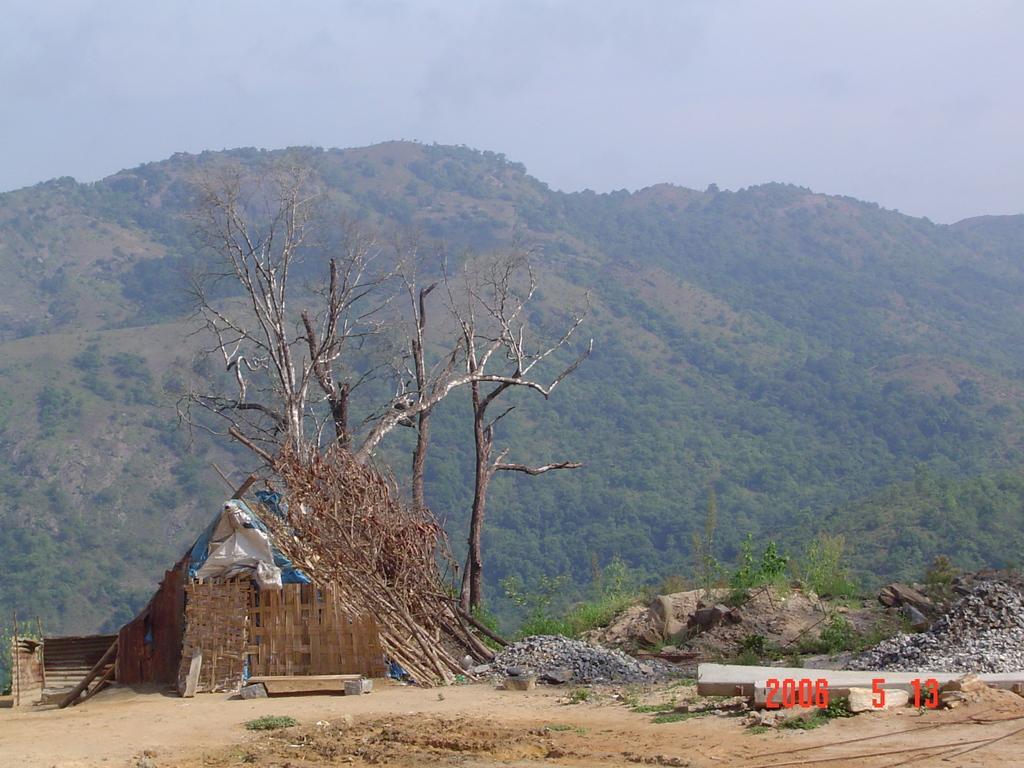Can you describe this image briefly? In this image there is the sky towards the top of the image, there are mountains, there are trees on the mountains, there are plants, there is a hut, there are dried trees, there are stones, there are objects on the ground, there is a number towards the bottom of the image. 